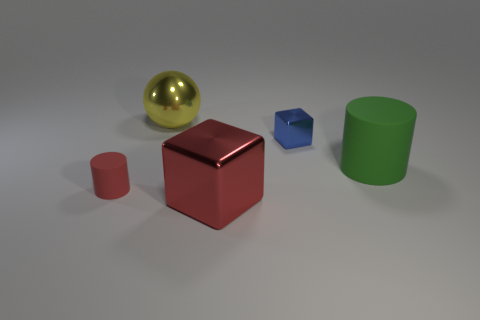Add 1 green shiny cubes. How many objects exist? 6 Subtract all balls. How many objects are left? 4 Add 1 tiny blue matte spheres. How many tiny blue matte spheres exist? 1 Subtract 0 blue cylinders. How many objects are left? 5 Subtract all brown rubber spheres. Subtract all yellow spheres. How many objects are left? 4 Add 2 big rubber cylinders. How many big rubber cylinders are left? 3 